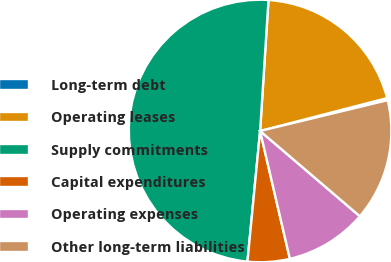Convert chart. <chart><loc_0><loc_0><loc_500><loc_500><pie_chart><fcel>Long-term debt<fcel>Operating leases<fcel>Supply commitments<fcel>Capital expenditures<fcel>Operating expenses<fcel>Other long-term liabilities<nl><fcel>0.26%<fcel>19.95%<fcel>49.48%<fcel>5.18%<fcel>10.1%<fcel>15.03%<nl></chart> 